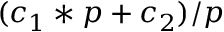Convert formula to latex. <formula><loc_0><loc_0><loc_500><loc_500>( c _ { 1 } * p + c _ { 2 } ) / p</formula> 